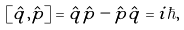Convert formula to latex. <formula><loc_0><loc_0><loc_500><loc_500>\left [ \hat { q } , \hat { p } \right ] = \hat { q } \hat { p } - \hat { p } \hat { q } = i \hbar { , }</formula> 